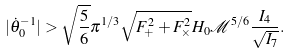Convert formula to latex. <formula><loc_0><loc_0><loc_500><loc_500>| \dot { \theta } _ { 0 } ^ { - 1 } | > \sqrt { \frac { 5 } { 6 } } \pi ^ { 1 / 3 } \sqrt { F _ { + } ^ { 2 } + F _ { \times } ^ { 2 } } H _ { 0 } \mathcal { M } ^ { 5 / 6 } \frac { I _ { 4 } } { \sqrt { I _ { 7 } } } .</formula> 